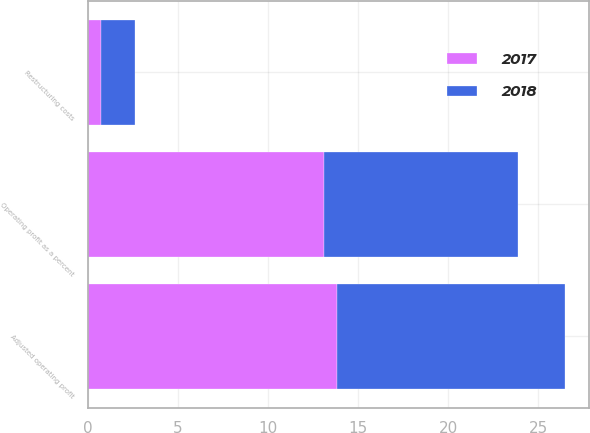Convert chart to OTSL. <chart><loc_0><loc_0><loc_500><loc_500><stacked_bar_chart><ecel><fcel>Operating profit as a percent<fcel>Restructuring costs<fcel>Adjusted operating profit<nl><fcel>2017<fcel>13.1<fcel>0.7<fcel>13.8<nl><fcel>2018<fcel>10.8<fcel>1.9<fcel>12.7<nl></chart> 